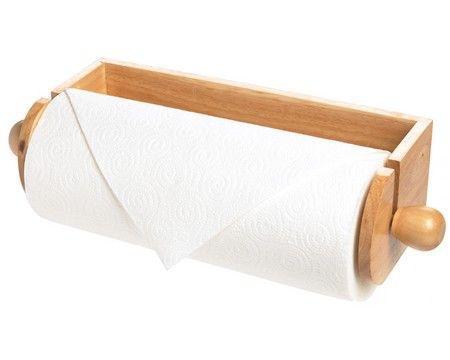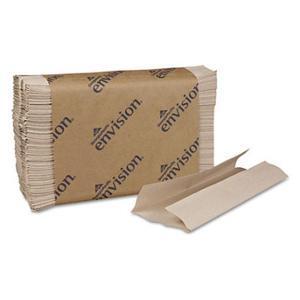The first image is the image on the left, the second image is the image on the right. Examine the images to the left and right. Is the description "No paper rolls are shown, but a stack of folded towels in a brown wrapper and a cardboard box are shown." accurate? Answer yes or no. No. The first image is the image on the left, the second image is the image on the right. Assess this claim about the two images: "At least one of the paper products is available by the roll.". Correct or not? Answer yes or no. Yes. 